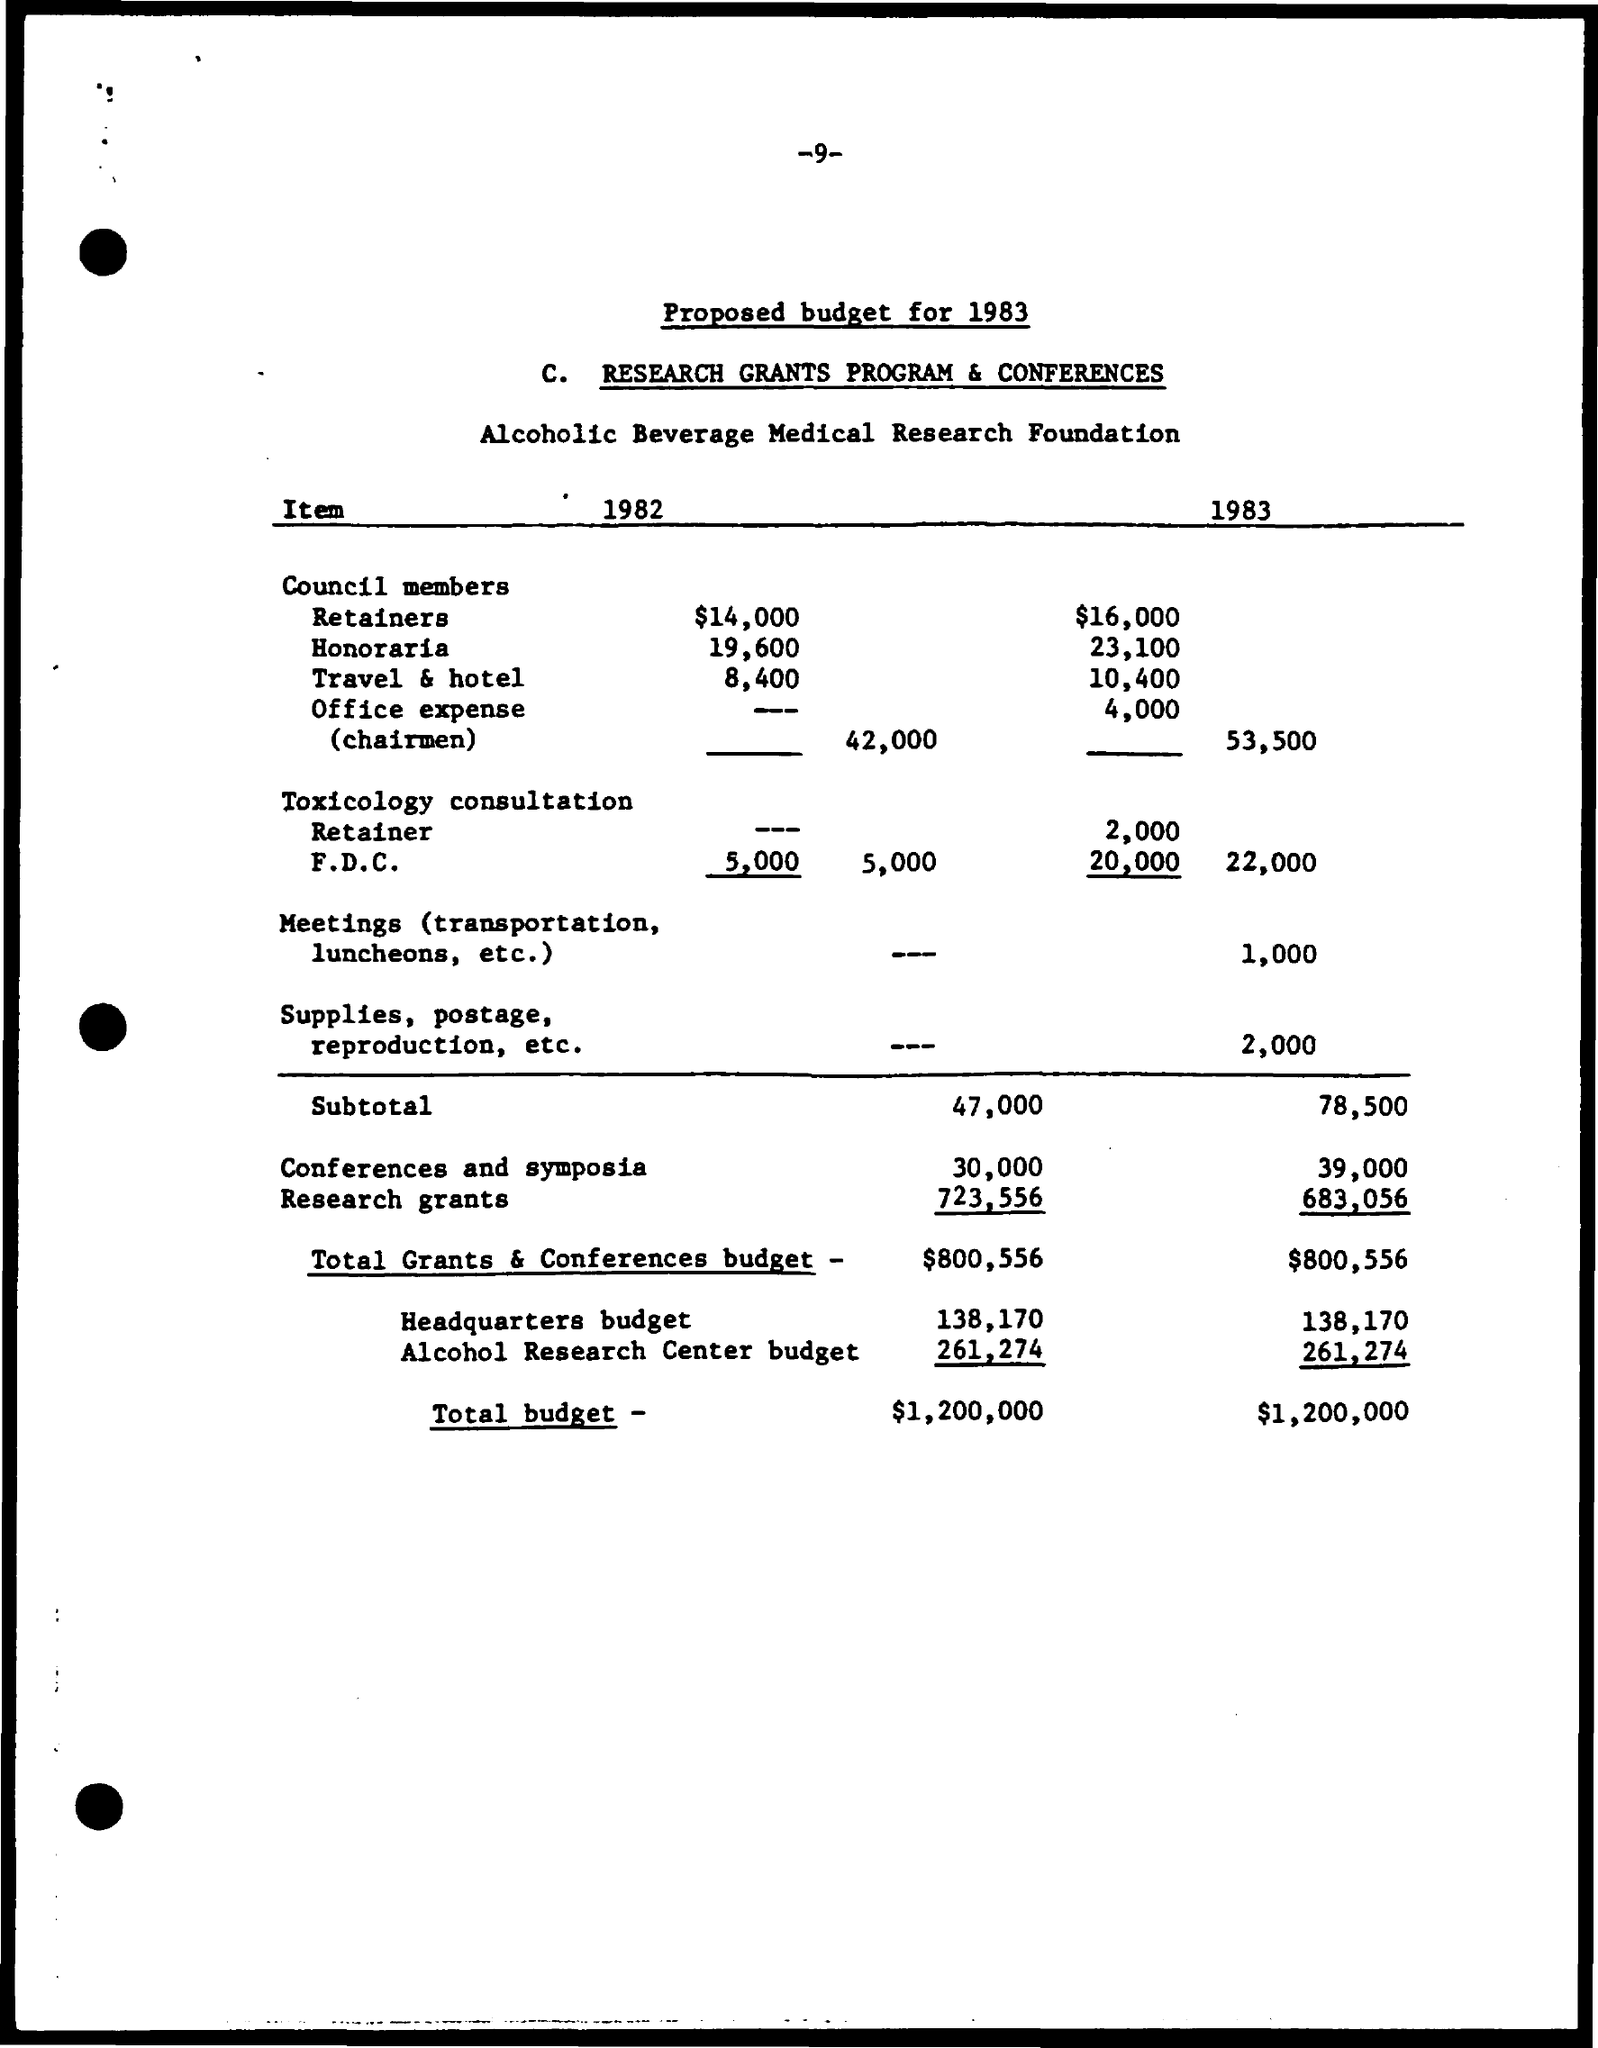What is the Title of the document?
Ensure brevity in your answer.  Proposed budget for 1983. What is cost for Retainers for 1982?
Provide a succinct answer. $14,000. What is cost for Retainers for 1983?
Offer a very short reply. $16,000. What is cost for Honoraria for 1982?
Offer a terse response. 19,600. What is cost for Honoraria for 1983?
Provide a succinct answer. 23,100. What is cost for Travel & hotel for 1982?
Your answer should be compact. 8,400. What is cost for Travel & hotel for 1983?
Offer a terse response. 10,400. What is cost for Office expense for 1983?
Offer a terse response. 4,000. What is Subtotal for 1982?
Provide a succinct answer. 47,000. What is Subtotal for 1983?
Your response must be concise. 78,500. 